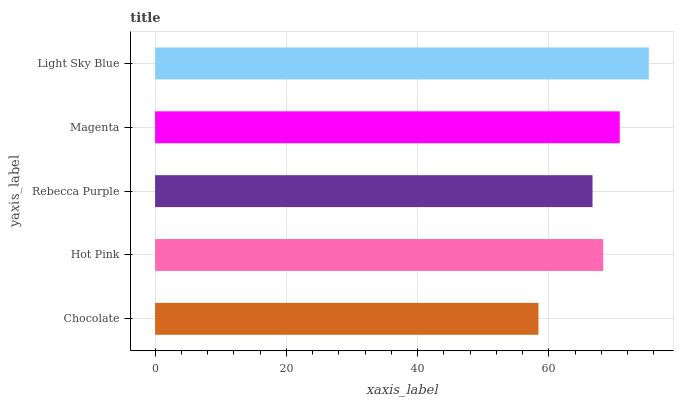Is Chocolate the minimum?
Answer yes or no. Yes. Is Light Sky Blue the maximum?
Answer yes or no. Yes. Is Hot Pink the minimum?
Answer yes or no. No. Is Hot Pink the maximum?
Answer yes or no. No. Is Hot Pink greater than Chocolate?
Answer yes or no. Yes. Is Chocolate less than Hot Pink?
Answer yes or no. Yes. Is Chocolate greater than Hot Pink?
Answer yes or no. No. Is Hot Pink less than Chocolate?
Answer yes or no. No. Is Hot Pink the high median?
Answer yes or no. Yes. Is Hot Pink the low median?
Answer yes or no. Yes. Is Magenta the high median?
Answer yes or no. No. Is Magenta the low median?
Answer yes or no. No. 